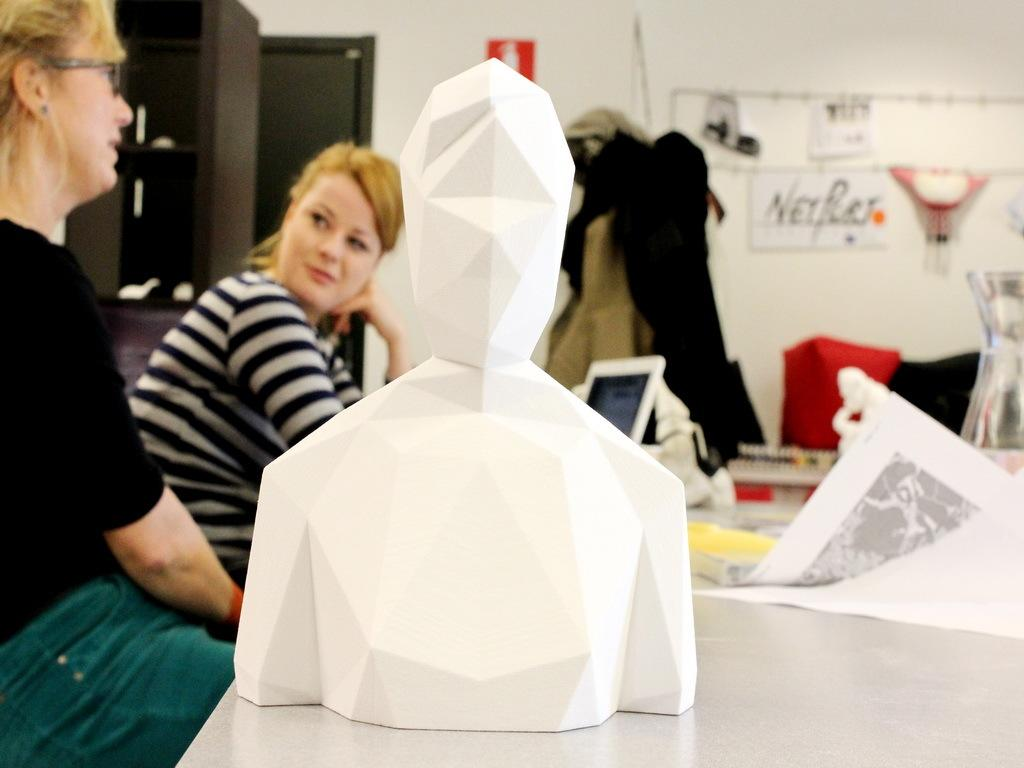How many women are present in the image? There are two women in the image. What are the women doing in the image? Both women are sitting. What type of art can be seen in the image? There is a paper art in the image. What can be seen in the background of the image? There is a wall and a cabinet in the background of the image. What type of journey are the women embarking on in the image? There is no indication of a journey in the image; the women are simply sitting. What observation can be made about the wall in the image? There is no specific observation about the wall in the image, as it is simply a part of the background. 